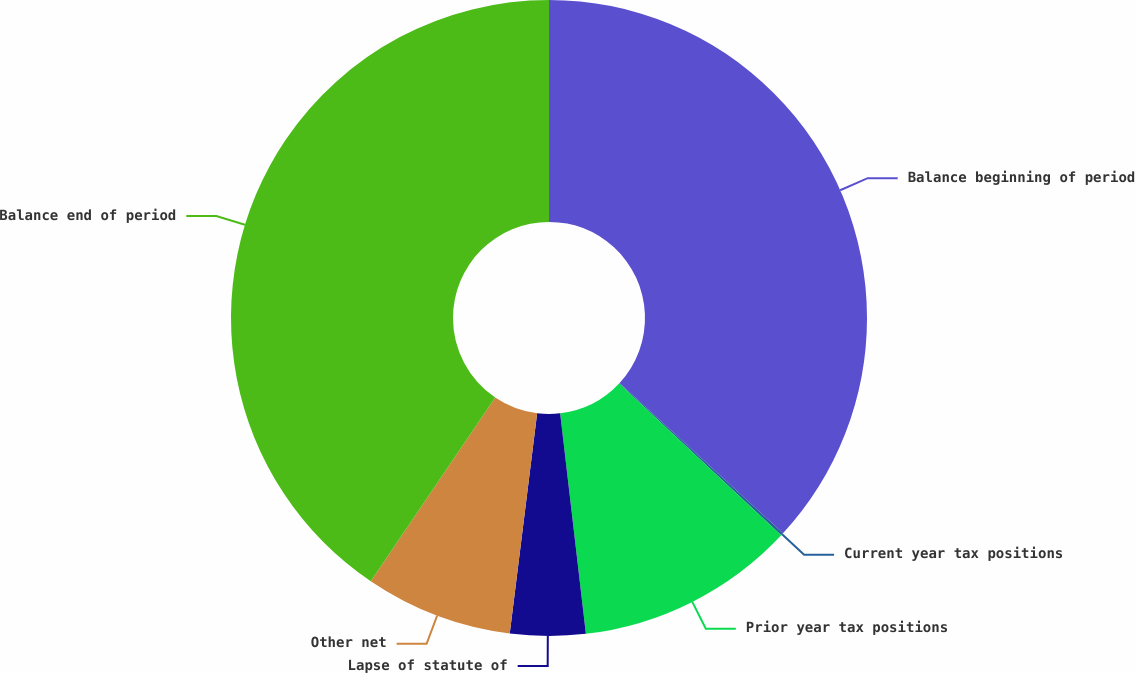Convert chart. <chart><loc_0><loc_0><loc_500><loc_500><pie_chart><fcel>Balance beginning of period<fcel>Current year tax positions<fcel>Prior year tax positions<fcel>Lapse of statute of<fcel>Other net<fcel>Balance end of period<nl><fcel>36.84%<fcel>0.13%<fcel>11.18%<fcel>3.82%<fcel>7.5%<fcel>40.53%<nl></chart> 